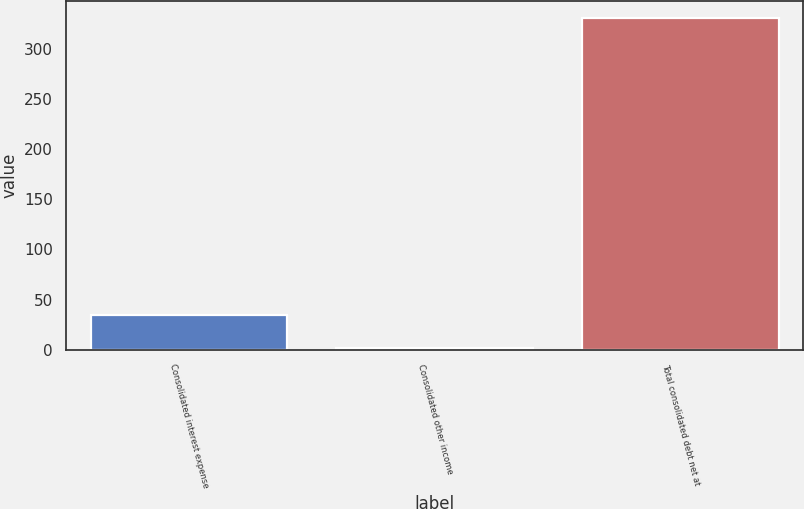Convert chart. <chart><loc_0><loc_0><loc_500><loc_500><bar_chart><fcel>Consolidated interest expense<fcel>Consolidated other income<fcel>Total consolidated debt net at<nl><fcel>34.8<fcel>1.9<fcel>330.9<nl></chart> 